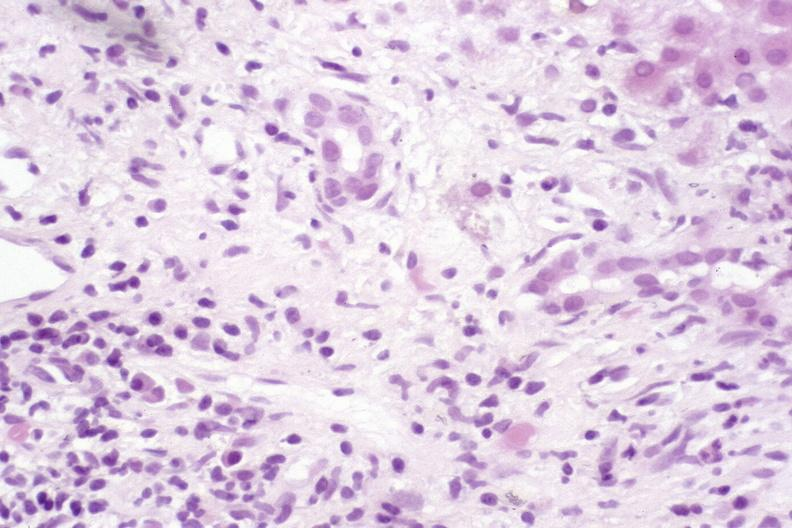s pituitary present?
Answer the question using a single word or phrase. No 